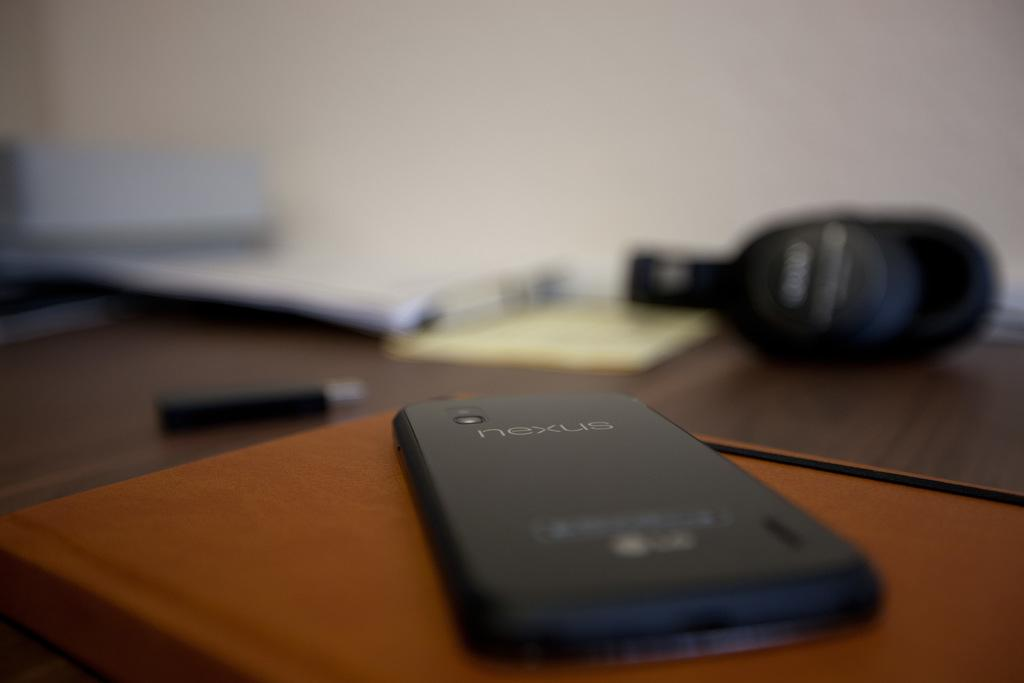Provide a one-sentence caption for the provided image. A nexus phone laying on a brown book. 